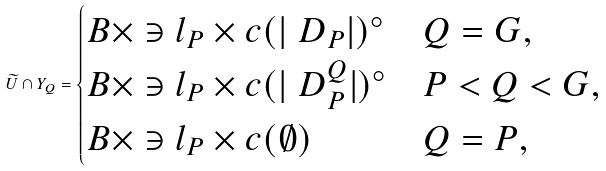Convert formula to latex. <formula><loc_0><loc_0><loc_500><loc_500>\widetilde { U } \cap Y _ { Q } = \begin{cases} B \times \ni l _ { P } \times c ( | \ D _ { P } | ) ^ { \circ } & Q = G , \\ B \times \ni l _ { P } \times c ( | \ D _ { P } ^ { Q } | ) ^ { \circ } & P < Q < G , \\ B \times \ni l _ { P } \times c ( \emptyset ) & Q = P , \end{cases}</formula> 